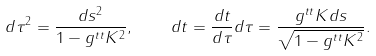<formula> <loc_0><loc_0><loc_500><loc_500>d \tau ^ { 2 } = \frac { d s ^ { 2 } } { 1 - g ^ { t t } K ^ { 2 } } , \quad d t = \frac { d t } { d \tau } d \tau = \frac { g ^ { t t } K d s } { \sqrt { 1 - g ^ { t t } K ^ { 2 } } } .</formula> 